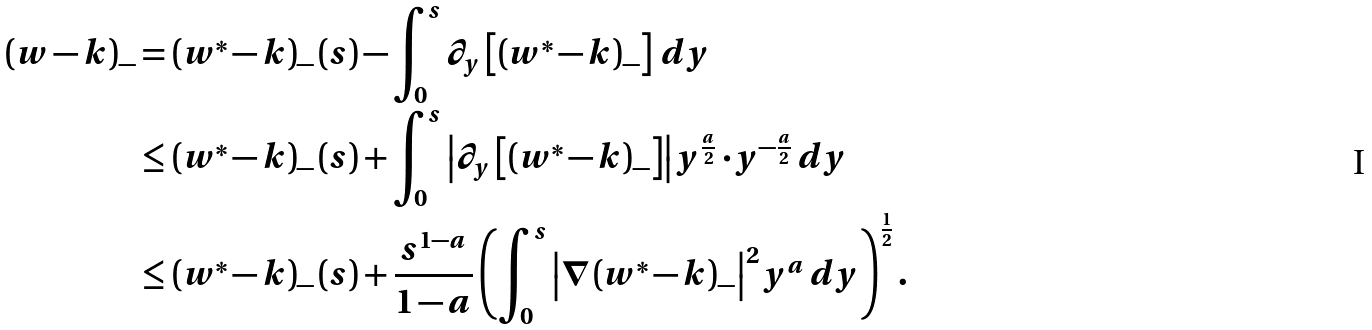Convert formula to latex. <formula><loc_0><loc_0><loc_500><loc_500>\left ( w - k \right ) _ { - } & = \left ( w ^ { \ast } - k \right ) _ { - } ( s ) - \int _ { 0 } ^ { s } \partial _ { y } \left [ \left ( w ^ { \ast } - k \right ) _ { - } \right ] \, d y \\ & \leq \left ( w ^ { \ast } - k \right ) _ { - } ( s ) + \int _ { 0 } ^ { s } \left | \partial _ { y } \left [ \left ( w ^ { \ast } - k \right ) _ { - } \right ] \right | y ^ { \frac { a } { 2 } } \cdot y ^ { - \frac { a } { 2 } } \, d y \\ & \leq \left ( w ^ { \ast } - k \right ) _ { - } ( s ) + \frac { s ^ { 1 - a } } { 1 - a } \left ( \int _ { 0 } ^ { s } \left | \nabla \left ( w ^ { \ast } - k \right ) _ { - } \right | ^ { 2 } y ^ { a } \, d y \right ) ^ { \frac { 1 } { 2 } } .</formula> 